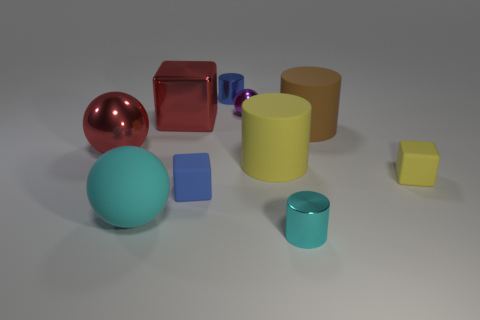Subtract all balls. How many objects are left? 7 Subtract all yellow cubes. Subtract all blue metallic things. How many objects are left? 8 Add 8 large yellow things. How many large yellow things are left? 9 Add 2 purple metallic cylinders. How many purple metallic cylinders exist? 2 Subtract 0 red cylinders. How many objects are left? 10 